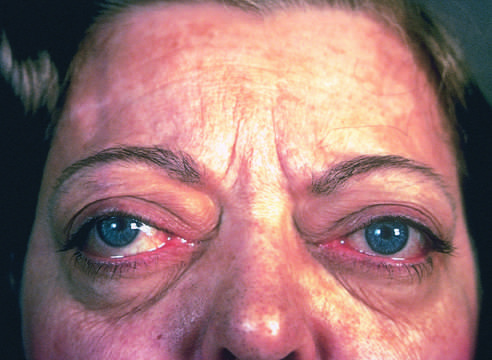what is one of the classic features of this disorder?
Answer the question using a single word or phrase. A wide-eyed 